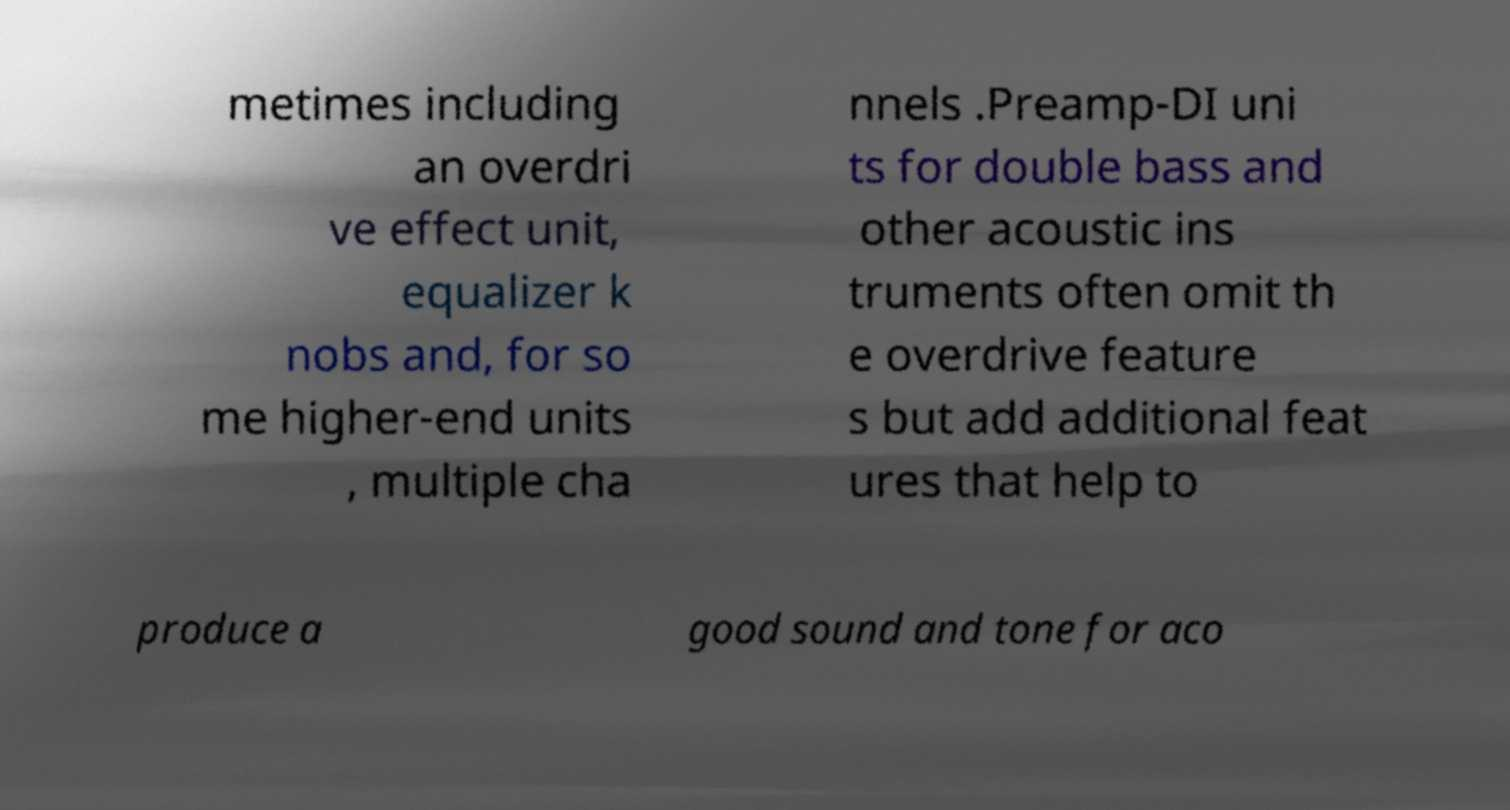Could you extract and type out the text from this image? metimes including an overdri ve effect unit, equalizer k nobs and, for so me higher-end units , multiple cha nnels .Preamp-DI uni ts for double bass and other acoustic ins truments often omit th e overdrive feature s but add additional feat ures that help to produce a good sound and tone for aco 